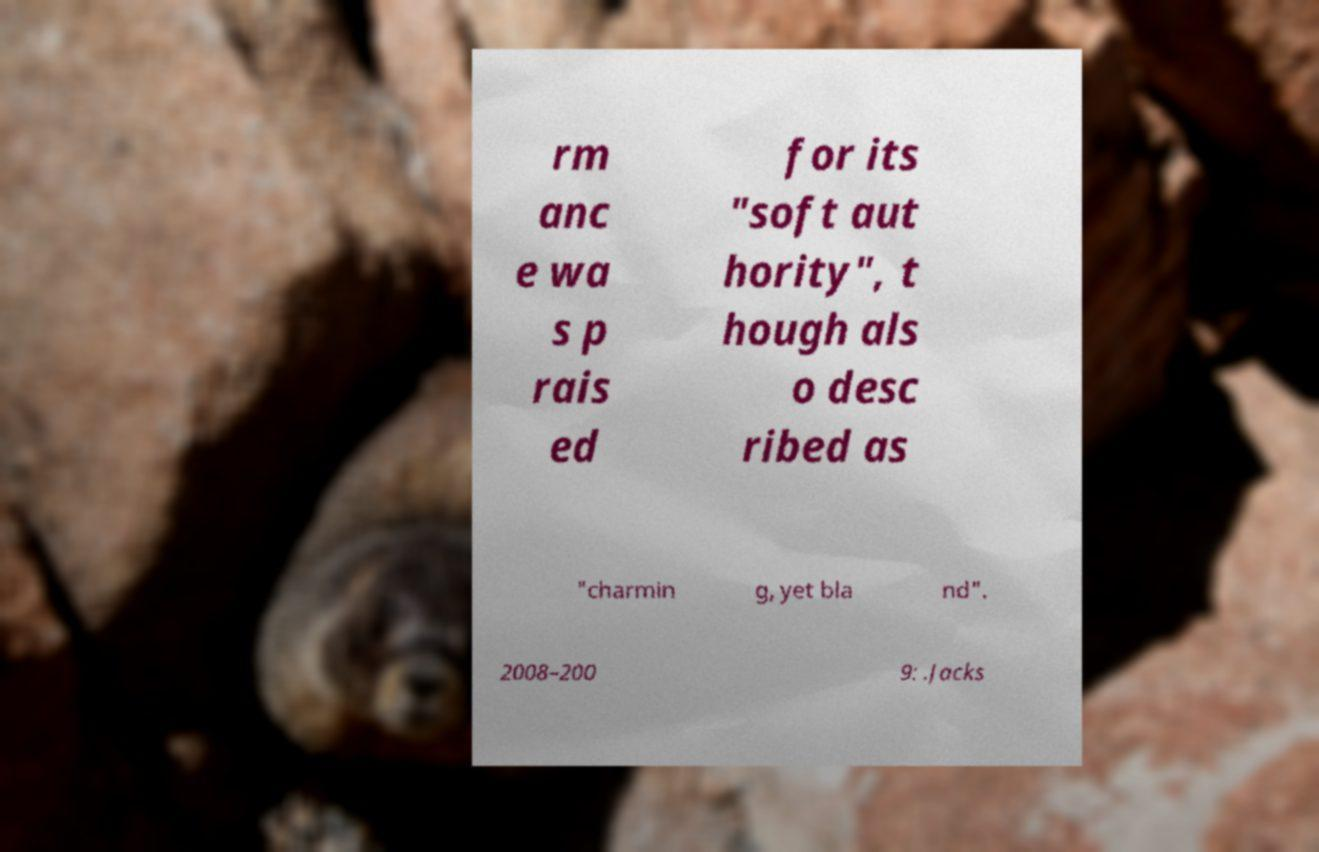I need the written content from this picture converted into text. Can you do that? rm anc e wa s p rais ed for its "soft aut hority", t hough als o desc ribed as "charmin g, yet bla nd". 2008–200 9: .Jacks 